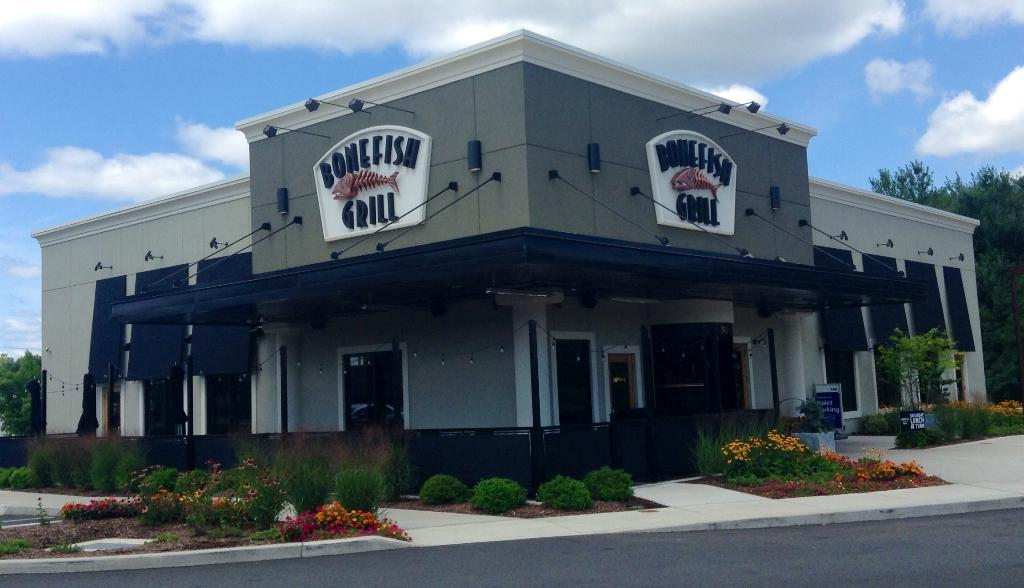What types of living organisms can be seen in the image? Plants and flowers are visible in the image. What type of man-made structure can be seen in the image? There is a building in the image. What is the primary mode of transportation visible in the image? There is a road in the image, which suggests that vehicles may be used for transportation. What can be seen in the background of the image? Trees and the sky are visible in the background of the image. What is the condition of the sky in the image? The sky has clouds in it. What type of wine is being served at the basketball game in the image? There is no wine or basketball game present in the image. What is the border of the image made of? The image does not have a border, so it cannot be made of any material. 